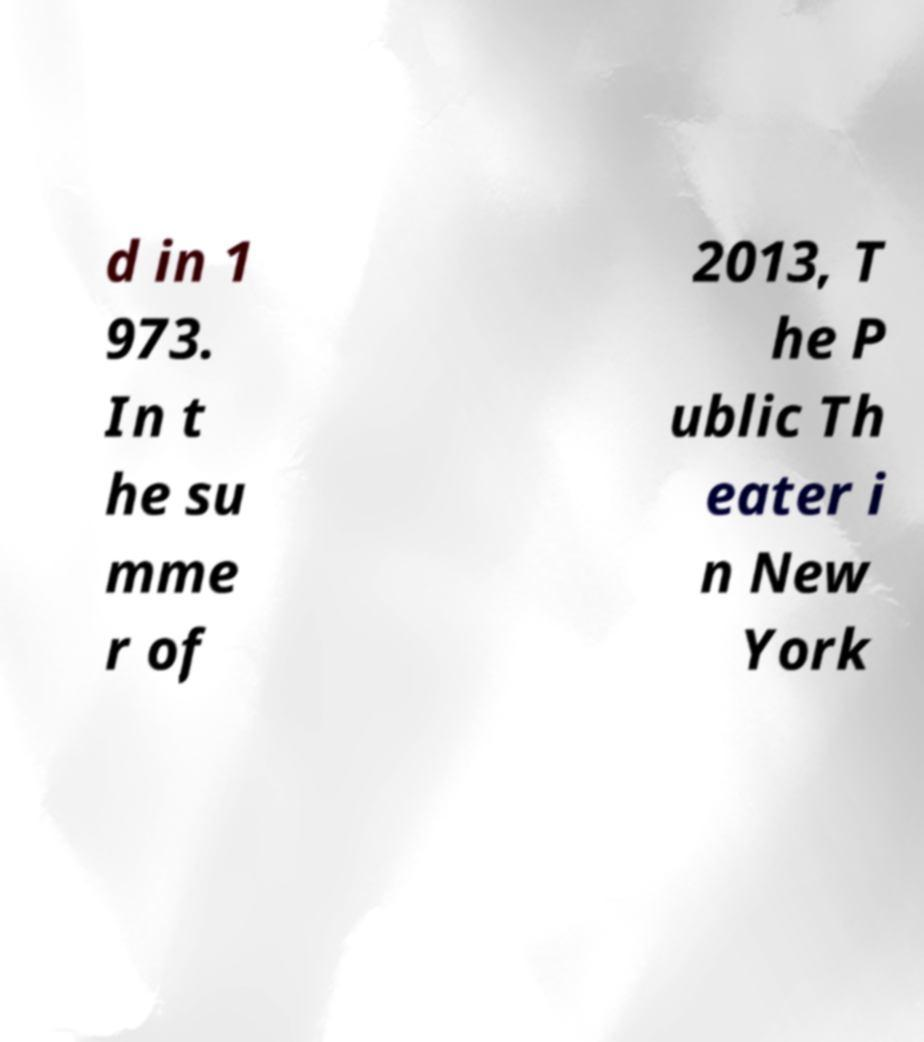Could you extract and type out the text from this image? d in 1 973. In t he su mme r of 2013, T he P ublic Th eater i n New York 